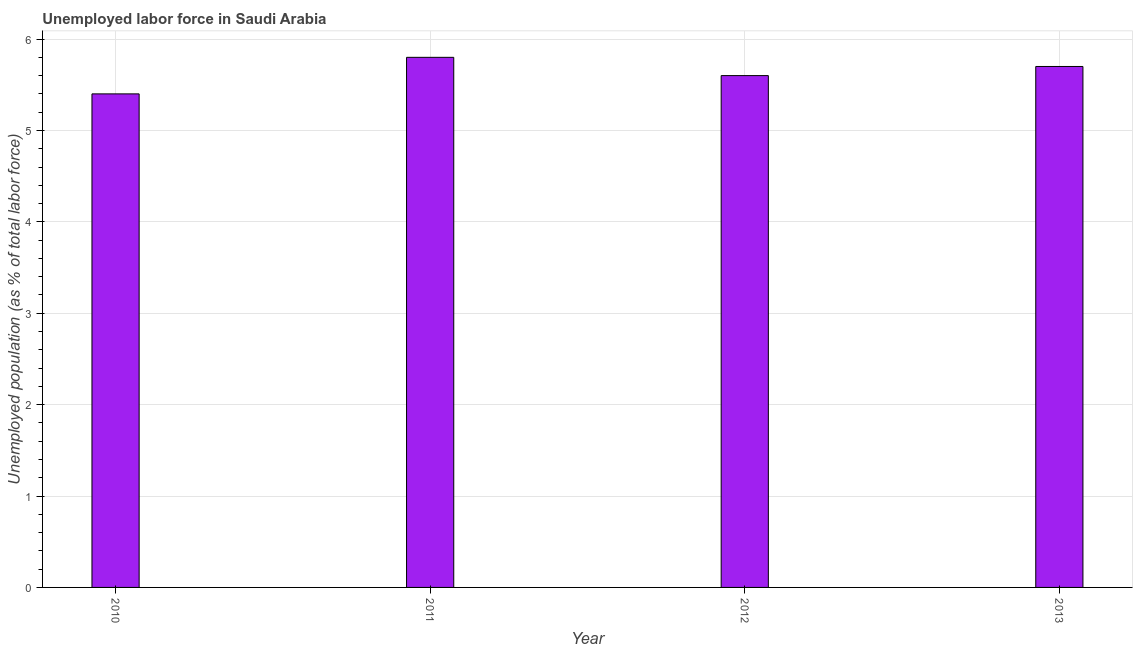Does the graph contain any zero values?
Your answer should be very brief. No. Does the graph contain grids?
Offer a terse response. Yes. What is the title of the graph?
Provide a short and direct response. Unemployed labor force in Saudi Arabia. What is the label or title of the X-axis?
Offer a terse response. Year. What is the label or title of the Y-axis?
Ensure brevity in your answer.  Unemployed population (as % of total labor force). What is the total unemployed population in 2013?
Keep it short and to the point. 5.7. Across all years, what is the maximum total unemployed population?
Offer a terse response. 5.8. Across all years, what is the minimum total unemployed population?
Your answer should be very brief. 5.4. In which year was the total unemployed population minimum?
Offer a very short reply. 2010. What is the sum of the total unemployed population?
Your answer should be compact. 22.5. What is the average total unemployed population per year?
Offer a terse response. 5.62. What is the median total unemployed population?
Keep it short and to the point. 5.65. In how many years, is the total unemployed population greater than 5.4 %?
Your answer should be very brief. 4. What is the ratio of the total unemployed population in 2012 to that in 2013?
Your response must be concise. 0.98. Is the total unemployed population in 2010 less than that in 2013?
Keep it short and to the point. Yes. What is the difference between the highest and the second highest total unemployed population?
Provide a short and direct response. 0.1. Is the sum of the total unemployed population in 2012 and 2013 greater than the maximum total unemployed population across all years?
Your answer should be very brief. Yes. In how many years, is the total unemployed population greater than the average total unemployed population taken over all years?
Offer a terse response. 2. Are all the bars in the graph horizontal?
Give a very brief answer. No. Are the values on the major ticks of Y-axis written in scientific E-notation?
Your answer should be compact. No. What is the Unemployed population (as % of total labor force) in 2010?
Offer a terse response. 5.4. What is the Unemployed population (as % of total labor force) of 2011?
Offer a terse response. 5.8. What is the Unemployed population (as % of total labor force) in 2012?
Provide a succinct answer. 5.6. What is the Unemployed population (as % of total labor force) in 2013?
Keep it short and to the point. 5.7. What is the difference between the Unemployed population (as % of total labor force) in 2010 and 2012?
Provide a short and direct response. -0.2. What is the difference between the Unemployed population (as % of total labor force) in 2011 and 2012?
Ensure brevity in your answer.  0.2. What is the difference between the Unemployed population (as % of total labor force) in 2012 and 2013?
Provide a succinct answer. -0.1. What is the ratio of the Unemployed population (as % of total labor force) in 2010 to that in 2011?
Ensure brevity in your answer.  0.93. What is the ratio of the Unemployed population (as % of total labor force) in 2010 to that in 2013?
Provide a short and direct response. 0.95. What is the ratio of the Unemployed population (as % of total labor force) in 2011 to that in 2012?
Keep it short and to the point. 1.04. What is the ratio of the Unemployed population (as % of total labor force) in 2011 to that in 2013?
Provide a succinct answer. 1.02. 